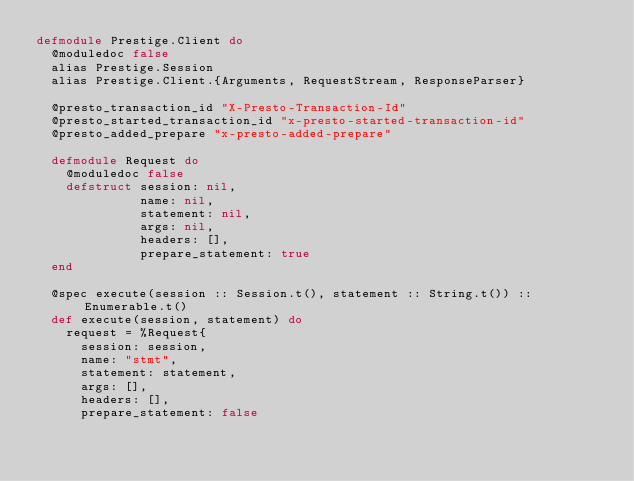<code> <loc_0><loc_0><loc_500><loc_500><_Elixir_>defmodule Prestige.Client do
  @moduledoc false
  alias Prestige.Session
  alias Prestige.Client.{Arguments, RequestStream, ResponseParser}

  @presto_transaction_id "X-Presto-Transaction-Id"
  @presto_started_transaction_id "x-presto-started-transaction-id"
  @presto_added_prepare "x-presto-added-prepare"

  defmodule Request do
    @moduledoc false
    defstruct session: nil,
              name: nil,
              statement: nil,
              args: nil,
              headers: [],
              prepare_statement: true
  end

  @spec execute(session :: Session.t(), statement :: String.t()) :: Enumerable.t()
  def execute(session, statement) do
    request = %Request{
      session: session,
      name: "stmt",
      statement: statement,
      args: [],
      headers: [],
      prepare_statement: false</code> 